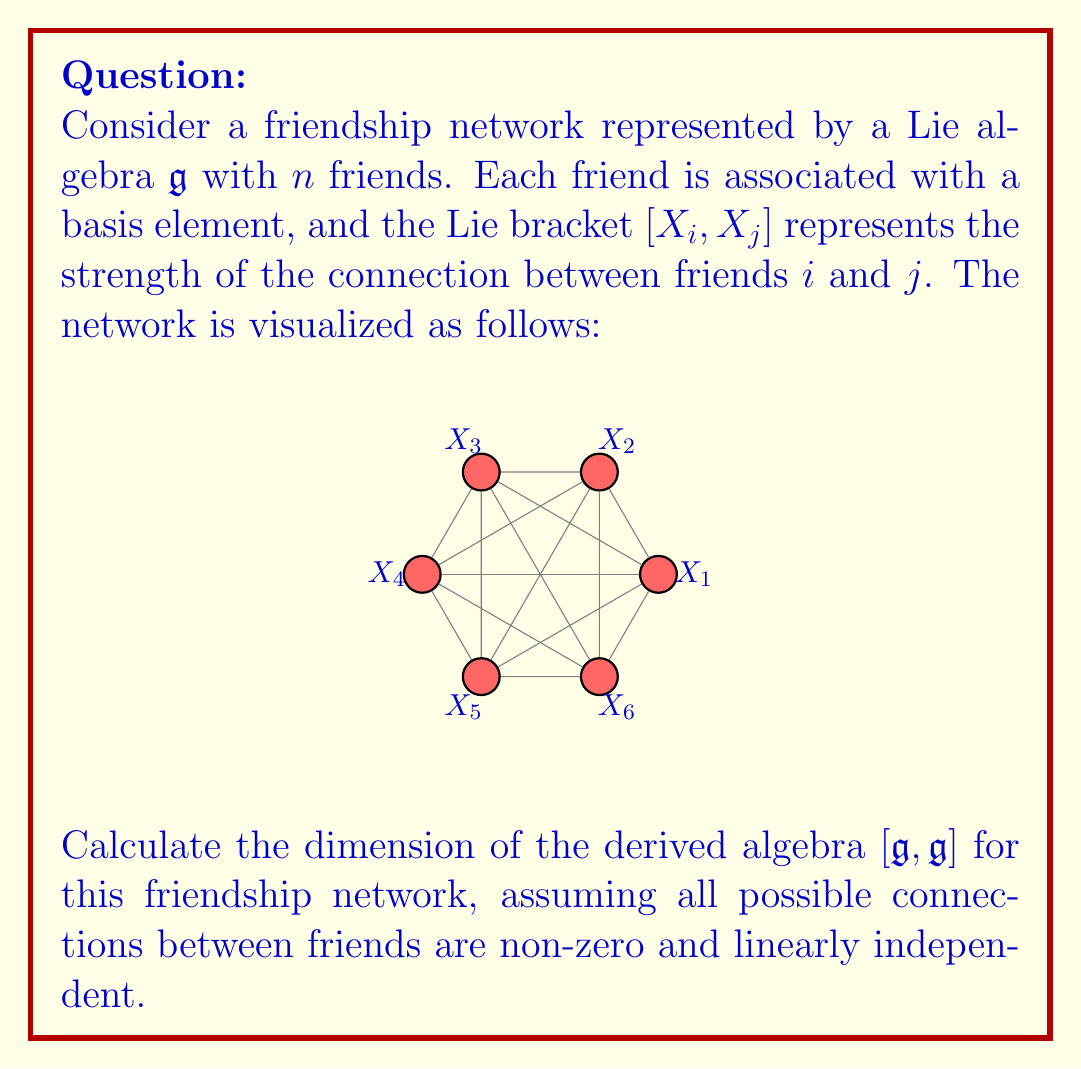Show me your answer to this math problem. To calculate the dimension of the derived algebra $[\mathfrak{g}, \mathfrak{g}]$, we need to follow these steps:

1) The derived algebra $[\mathfrak{g}, \mathfrak{g}]$ is generated by all possible Lie brackets $[X_i, X_j]$ where $i \neq j$.

2) In a Lie algebra, $[X_i, X_j] = -[X_j, X_i]$, so we only need to consider $i < j$.

3) The number of such pairs $(i,j)$ with $i < j$ in a network of $n$ friends is:

   $$\binom{n}{2} = \frac{n(n-1)}{2}$$

4) In this case, we have $n = 6$ friends. So the number of linearly independent elements in $[\mathfrak{g}, \mathfrak{g}]$ is:

   $$\binom{6}{2} = \frac{6(6-1)}{2} = \frac{6 \cdot 5}{2} = 15$$

5) Since all these elements are assumed to be non-zero and linearly independent, the dimension of $[\mathfrak{g}, \mathfrak{g}]$ is equal to this number.

Therefore, the dimension of the derived algebra $[\mathfrak{g}, \mathfrak{g}]$ for this friendship network is 15.
Answer: 15 